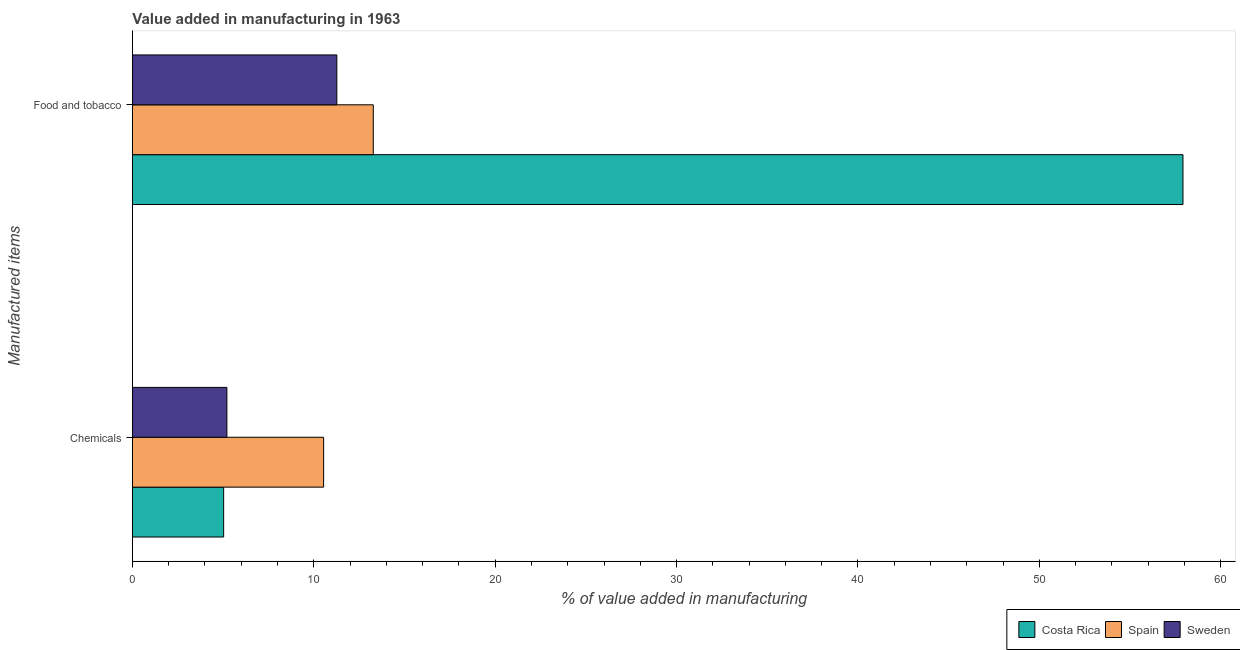How many different coloured bars are there?
Your answer should be very brief. 3. How many groups of bars are there?
Offer a very short reply. 2. Are the number of bars per tick equal to the number of legend labels?
Keep it short and to the point. Yes. Are the number of bars on each tick of the Y-axis equal?
Make the answer very short. Yes. How many bars are there on the 2nd tick from the top?
Your answer should be compact. 3. How many bars are there on the 2nd tick from the bottom?
Your answer should be very brief. 3. What is the label of the 1st group of bars from the top?
Offer a very short reply. Food and tobacco. What is the value added by  manufacturing chemicals in Costa Rica?
Your answer should be very brief. 5.03. Across all countries, what is the maximum value added by  manufacturing chemicals?
Keep it short and to the point. 10.54. Across all countries, what is the minimum value added by manufacturing food and tobacco?
Provide a short and direct response. 11.27. In which country was the value added by  manufacturing chemicals minimum?
Your answer should be very brief. Costa Rica. What is the total value added by  manufacturing chemicals in the graph?
Your answer should be very brief. 20.78. What is the difference between the value added by  manufacturing chemicals in Sweden and that in Costa Rica?
Your answer should be very brief. 0.18. What is the difference between the value added by manufacturing food and tobacco in Spain and the value added by  manufacturing chemicals in Sweden?
Give a very brief answer. 8.07. What is the average value added by manufacturing food and tobacco per country?
Your answer should be compact. 27.49. What is the difference between the value added by  manufacturing chemicals and value added by manufacturing food and tobacco in Sweden?
Offer a terse response. -6.06. What is the ratio of the value added by manufacturing food and tobacco in Spain to that in Sweden?
Keep it short and to the point. 1.18. Does the graph contain any zero values?
Your response must be concise. No. Where does the legend appear in the graph?
Your answer should be compact. Bottom right. How many legend labels are there?
Make the answer very short. 3. How are the legend labels stacked?
Offer a very short reply. Horizontal. What is the title of the graph?
Your response must be concise. Value added in manufacturing in 1963. What is the label or title of the X-axis?
Give a very brief answer. % of value added in manufacturing. What is the label or title of the Y-axis?
Give a very brief answer. Manufactured items. What is the % of value added in manufacturing in Costa Rica in Chemicals?
Offer a terse response. 5.03. What is the % of value added in manufacturing of Spain in Chemicals?
Make the answer very short. 10.54. What is the % of value added in manufacturing of Sweden in Chemicals?
Give a very brief answer. 5.21. What is the % of value added in manufacturing in Costa Rica in Food and tobacco?
Your response must be concise. 57.92. What is the % of value added in manufacturing of Spain in Food and tobacco?
Ensure brevity in your answer.  13.28. What is the % of value added in manufacturing in Sweden in Food and tobacco?
Give a very brief answer. 11.27. Across all Manufactured items, what is the maximum % of value added in manufacturing in Costa Rica?
Ensure brevity in your answer.  57.92. Across all Manufactured items, what is the maximum % of value added in manufacturing of Spain?
Make the answer very short. 13.28. Across all Manufactured items, what is the maximum % of value added in manufacturing in Sweden?
Ensure brevity in your answer.  11.27. Across all Manufactured items, what is the minimum % of value added in manufacturing of Costa Rica?
Your answer should be compact. 5.03. Across all Manufactured items, what is the minimum % of value added in manufacturing in Spain?
Keep it short and to the point. 10.54. Across all Manufactured items, what is the minimum % of value added in manufacturing in Sweden?
Your answer should be very brief. 5.21. What is the total % of value added in manufacturing in Costa Rica in the graph?
Ensure brevity in your answer.  62.95. What is the total % of value added in manufacturing in Spain in the graph?
Your response must be concise. 23.82. What is the total % of value added in manufacturing in Sweden in the graph?
Give a very brief answer. 16.48. What is the difference between the % of value added in manufacturing of Costa Rica in Chemicals and that in Food and tobacco?
Your response must be concise. -52.89. What is the difference between the % of value added in manufacturing of Spain in Chemicals and that in Food and tobacco?
Provide a succinct answer. -2.74. What is the difference between the % of value added in manufacturing of Sweden in Chemicals and that in Food and tobacco?
Your response must be concise. -6.06. What is the difference between the % of value added in manufacturing in Costa Rica in Chemicals and the % of value added in manufacturing in Spain in Food and tobacco?
Your answer should be compact. -8.25. What is the difference between the % of value added in manufacturing in Costa Rica in Chemicals and the % of value added in manufacturing in Sweden in Food and tobacco?
Give a very brief answer. -6.24. What is the difference between the % of value added in manufacturing in Spain in Chemicals and the % of value added in manufacturing in Sweden in Food and tobacco?
Your answer should be compact. -0.73. What is the average % of value added in manufacturing in Costa Rica per Manufactured items?
Ensure brevity in your answer.  31.47. What is the average % of value added in manufacturing in Spain per Manufactured items?
Keep it short and to the point. 11.91. What is the average % of value added in manufacturing in Sweden per Manufactured items?
Provide a succinct answer. 8.24. What is the difference between the % of value added in manufacturing in Costa Rica and % of value added in manufacturing in Spain in Chemicals?
Your answer should be very brief. -5.51. What is the difference between the % of value added in manufacturing of Costa Rica and % of value added in manufacturing of Sweden in Chemicals?
Give a very brief answer. -0.18. What is the difference between the % of value added in manufacturing of Spain and % of value added in manufacturing of Sweden in Chemicals?
Offer a very short reply. 5.33. What is the difference between the % of value added in manufacturing of Costa Rica and % of value added in manufacturing of Spain in Food and tobacco?
Give a very brief answer. 44.64. What is the difference between the % of value added in manufacturing in Costa Rica and % of value added in manufacturing in Sweden in Food and tobacco?
Make the answer very short. 46.65. What is the difference between the % of value added in manufacturing of Spain and % of value added in manufacturing of Sweden in Food and tobacco?
Your answer should be compact. 2.01. What is the ratio of the % of value added in manufacturing in Costa Rica in Chemicals to that in Food and tobacco?
Offer a terse response. 0.09. What is the ratio of the % of value added in manufacturing of Spain in Chemicals to that in Food and tobacco?
Your response must be concise. 0.79. What is the ratio of the % of value added in manufacturing of Sweden in Chemicals to that in Food and tobacco?
Provide a short and direct response. 0.46. What is the difference between the highest and the second highest % of value added in manufacturing of Costa Rica?
Offer a terse response. 52.89. What is the difference between the highest and the second highest % of value added in manufacturing in Spain?
Offer a very short reply. 2.74. What is the difference between the highest and the second highest % of value added in manufacturing in Sweden?
Your answer should be compact. 6.06. What is the difference between the highest and the lowest % of value added in manufacturing of Costa Rica?
Your answer should be very brief. 52.89. What is the difference between the highest and the lowest % of value added in manufacturing in Spain?
Give a very brief answer. 2.74. What is the difference between the highest and the lowest % of value added in manufacturing in Sweden?
Keep it short and to the point. 6.06. 